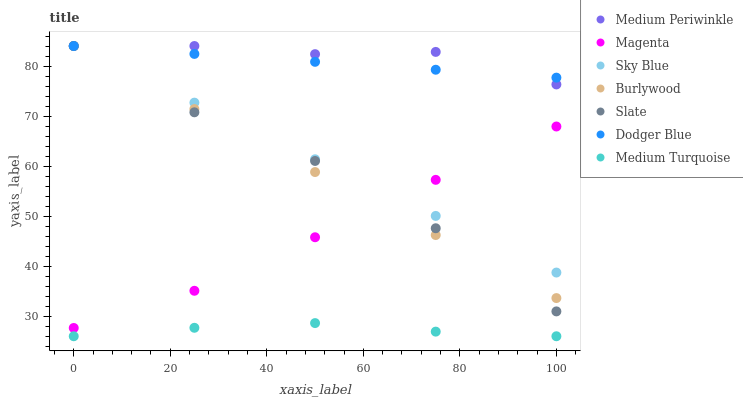Does Medium Turquoise have the minimum area under the curve?
Answer yes or no. Yes. Does Medium Periwinkle have the maximum area under the curve?
Answer yes or no. Yes. Does Slate have the minimum area under the curve?
Answer yes or no. No. Does Slate have the maximum area under the curve?
Answer yes or no. No. Is Dodger Blue the smoothest?
Answer yes or no. Yes. Is Medium Periwinkle the roughest?
Answer yes or no. Yes. Is Slate the smoothest?
Answer yes or no. No. Is Slate the roughest?
Answer yes or no. No. Does Medium Turquoise have the lowest value?
Answer yes or no. Yes. Does Slate have the lowest value?
Answer yes or no. No. Does Sky Blue have the highest value?
Answer yes or no. Yes. Does Medium Turquoise have the highest value?
Answer yes or no. No. Is Medium Turquoise less than Sky Blue?
Answer yes or no. Yes. Is Sky Blue greater than Medium Turquoise?
Answer yes or no. Yes. Does Slate intersect Burlywood?
Answer yes or no. Yes. Is Slate less than Burlywood?
Answer yes or no. No. Is Slate greater than Burlywood?
Answer yes or no. No. Does Medium Turquoise intersect Sky Blue?
Answer yes or no. No. 